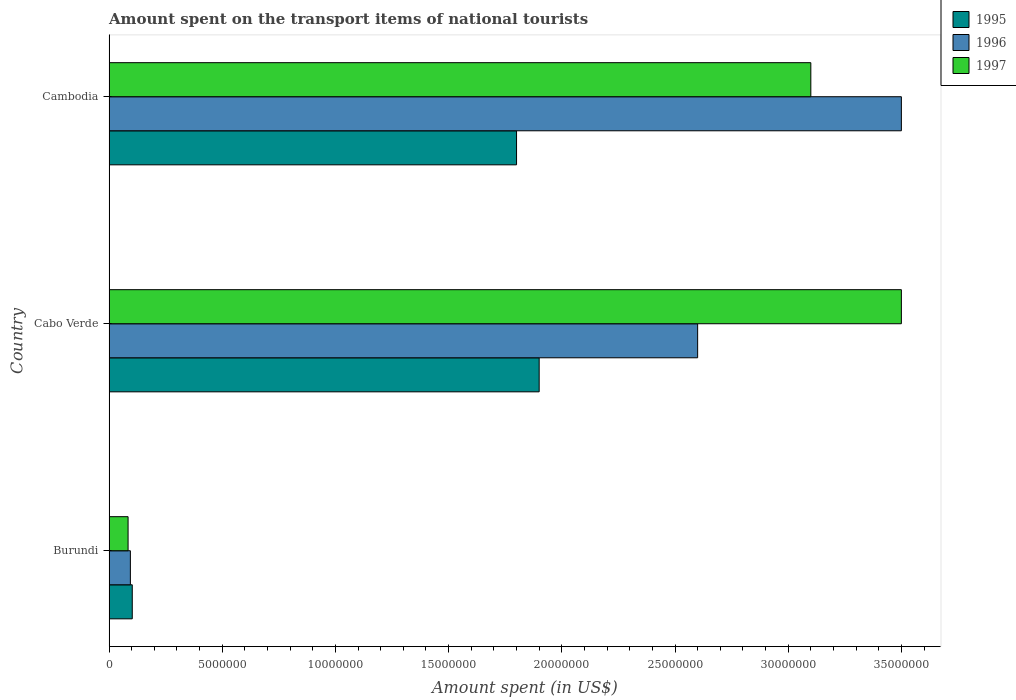How many different coloured bars are there?
Offer a terse response. 3. How many groups of bars are there?
Provide a succinct answer. 3. Are the number of bars on each tick of the Y-axis equal?
Make the answer very short. Yes. How many bars are there on the 2nd tick from the bottom?
Offer a terse response. 3. What is the label of the 2nd group of bars from the top?
Keep it short and to the point. Cabo Verde. In how many cases, is the number of bars for a given country not equal to the number of legend labels?
Offer a terse response. 0. What is the amount spent on the transport items of national tourists in 1996 in Cabo Verde?
Provide a succinct answer. 2.60e+07. Across all countries, what is the maximum amount spent on the transport items of national tourists in 1997?
Keep it short and to the point. 3.50e+07. Across all countries, what is the minimum amount spent on the transport items of national tourists in 1997?
Your answer should be very brief. 8.40e+05. In which country was the amount spent on the transport items of national tourists in 1996 maximum?
Offer a terse response. Cambodia. In which country was the amount spent on the transport items of national tourists in 1995 minimum?
Provide a succinct answer. Burundi. What is the total amount spent on the transport items of national tourists in 1996 in the graph?
Offer a very short reply. 6.19e+07. What is the difference between the amount spent on the transport items of national tourists in 1996 in Cabo Verde and that in Cambodia?
Your answer should be compact. -9.00e+06. What is the difference between the amount spent on the transport items of national tourists in 1995 in Cabo Verde and the amount spent on the transport items of national tourists in 1997 in Cambodia?
Offer a very short reply. -1.20e+07. What is the average amount spent on the transport items of national tourists in 1996 per country?
Your response must be concise. 2.06e+07. What is the difference between the amount spent on the transport items of national tourists in 1995 and amount spent on the transport items of national tourists in 1996 in Burundi?
Ensure brevity in your answer.  8.36e+04. What is the ratio of the amount spent on the transport items of national tourists in 1997 in Cabo Verde to that in Cambodia?
Keep it short and to the point. 1.13. What is the difference between the highest and the lowest amount spent on the transport items of national tourists in 1995?
Ensure brevity in your answer.  1.80e+07. In how many countries, is the amount spent on the transport items of national tourists in 1996 greater than the average amount spent on the transport items of national tourists in 1996 taken over all countries?
Keep it short and to the point. 2. Is it the case that in every country, the sum of the amount spent on the transport items of national tourists in 1995 and amount spent on the transport items of national tourists in 1997 is greater than the amount spent on the transport items of national tourists in 1996?
Offer a terse response. Yes. How many bars are there?
Your answer should be compact. 9. Are all the bars in the graph horizontal?
Provide a short and direct response. Yes. How many countries are there in the graph?
Make the answer very short. 3. What is the title of the graph?
Your answer should be compact. Amount spent on the transport items of national tourists. Does "2004" appear as one of the legend labels in the graph?
Provide a succinct answer. No. What is the label or title of the X-axis?
Offer a very short reply. Amount spent (in US$). What is the Amount spent (in US$) in 1995 in Burundi?
Offer a terse response. 1.02e+06. What is the Amount spent (in US$) of 1996 in Burundi?
Offer a very short reply. 9.41e+05. What is the Amount spent (in US$) in 1997 in Burundi?
Offer a terse response. 8.40e+05. What is the Amount spent (in US$) of 1995 in Cabo Verde?
Keep it short and to the point. 1.90e+07. What is the Amount spent (in US$) in 1996 in Cabo Verde?
Offer a very short reply. 2.60e+07. What is the Amount spent (in US$) of 1997 in Cabo Verde?
Your response must be concise. 3.50e+07. What is the Amount spent (in US$) of 1995 in Cambodia?
Give a very brief answer. 1.80e+07. What is the Amount spent (in US$) of 1996 in Cambodia?
Offer a very short reply. 3.50e+07. What is the Amount spent (in US$) of 1997 in Cambodia?
Your answer should be compact. 3.10e+07. Across all countries, what is the maximum Amount spent (in US$) in 1995?
Offer a terse response. 1.90e+07. Across all countries, what is the maximum Amount spent (in US$) in 1996?
Keep it short and to the point. 3.50e+07. Across all countries, what is the maximum Amount spent (in US$) in 1997?
Ensure brevity in your answer.  3.50e+07. Across all countries, what is the minimum Amount spent (in US$) of 1995?
Your answer should be very brief. 1.02e+06. Across all countries, what is the minimum Amount spent (in US$) of 1996?
Ensure brevity in your answer.  9.41e+05. Across all countries, what is the minimum Amount spent (in US$) of 1997?
Your answer should be very brief. 8.40e+05. What is the total Amount spent (in US$) in 1995 in the graph?
Offer a terse response. 3.80e+07. What is the total Amount spent (in US$) in 1996 in the graph?
Your answer should be compact. 6.19e+07. What is the total Amount spent (in US$) of 1997 in the graph?
Give a very brief answer. 6.68e+07. What is the difference between the Amount spent (in US$) in 1995 in Burundi and that in Cabo Verde?
Your answer should be compact. -1.80e+07. What is the difference between the Amount spent (in US$) in 1996 in Burundi and that in Cabo Verde?
Provide a short and direct response. -2.51e+07. What is the difference between the Amount spent (in US$) of 1997 in Burundi and that in Cabo Verde?
Provide a succinct answer. -3.42e+07. What is the difference between the Amount spent (in US$) of 1995 in Burundi and that in Cambodia?
Your response must be concise. -1.70e+07. What is the difference between the Amount spent (in US$) in 1996 in Burundi and that in Cambodia?
Offer a very short reply. -3.41e+07. What is the difference between the Amount spent (in US$) of 1997 in Burundi and that in Cambodia?
Ensure brevity in your answer.  -3.02e+07. What is the difference between the Amount spent (in US$) in 1996 in Cabo Verde and that in Cambodia?
Ensure brevity in your answer.  -9.00e+06. What is the difference between the Amount spent (in US$) of 1997 in Cabo Verde and that in Cambodia?
Make the answer very short. 4.00e+06. What is the difference between the Amount spent (in US$) of 1995 in Burundi and the Amount spent (in US$) of 1996 in Cabo Verde?
Your answer should be compact. -2.50e+07. What is the difference between the Amount spent (in US$) in 1995 in Burundi and the Amount spent (in US$) in 1997 in Cabo Verde?
Offer a terse response. -3.40e+07. What is the difference between the Amount spent (in US$) of 1996 in Burundi and the Amount spent (in US$) of 1997 in Cabo Verde?
Offer a terse response. -3.41e+07. What is the difference between the Amount spent (in US$) in 1995 in Burundi and the Amount spent (in US$) in 1996 in Cambodia?
Your answer should be very brief. -3.40e+07. What is the difference between the Amount spent (in US$) of 1995 in Burundi and the Amount spent (in US$) of 1997 in Cambodia?
Provide a succinct answer. -3.00e+07. What is the difference between the Amount spent (in US$) of 1996 in Burundi and the Amount spent (in US$) of 1997 in Cambodia?
Ensure brevity in your answer.  -3.01e+07. What is the difference between the Amount spent (in US$) of 1995 in Cabo Verde and the Amount spent (in US$) of 1996 in Cambodia?
Your answer should be compact. -1.60e+07. What is the difference between the Amount spent (in US$) of 1995 in Cabo Verde and the Amount spent (in US$) of 1997 in Cambodia?
Provide a short and direct response. -1.20e+07. What is the difference between the Amount spent (in US$) of 1996 in Cabo Verde and the Amount spent (in US$) of 1997 in Cambodia?
Your answer should be compact. -5.00e+06. What is the average Amount spent (in US$) of 1995 per country?
Your answer should be compact. 1.27e+07. What is the average Amount spent (in US$) of 1996 per country?
Your answer should be compact. 2.06e+07. What is the average Amount spent (in US$) in 1997 per country?
Give a very brief answer. 2.23e+07. What is the difference between the Amount spent (in US$) of 1995 and Amount spent (in US$) of 1996 in Burundi?
Your answer should be very brief. 8.36e+04. What is the difference between the Amount spent (in US$) in 1995 and Amount spent (in US$) in 1997 in Burundi?
Make the answer very short. 1.85e+05. What is the difference between the Amount spent (in US$) of 1996 and Amount spent (in US$) of 1997 in Burundi?
Your response must be concise. 1.01e+05. What is the difference between the Amount spent (in US$) in 1995 and Amount spent (in US$) in 1996 in Cabo Verde?
Provide a succinct answer. -7.00e+06. What is the difference between the Amount spent (in US$) of 1995 and Amount spent (in US$) of 1997 in Cabo Verde?
Your response must be concise. -1.60e+07. What is the difference between the Amount spent (in US$) in 1996 and Amount spent (in US$) in 1997 in Cabo Verde?
Your answer should be very brief. -9.00e+06. What is the difference between the Amount spent (in US$) of 1995 and Amount spent (in US$) of 1996 in Cambodia?
Make the answer very short. -1.70e+07. What is the difference between the Amount spent (in US$) in 1995 and Amount spent (in US$) in 1997 in Cambodia?
Give a very brief answer. -1.30e+07. What is the difference between the Amount spent (in US$) of 1996 and Amount spent (in US$) of 1997 in Cambodia?
Your answer should be compact. 4.00e+06. What is the ratio of the Amount spent (in US$) in 1995 in Burundi to that in Cabo Verde?
Offer a very short reply. 0.05. What is the ratio of the Amount spent (in US$) in 1996 in Burundi to that in Cabo Verde?
Your answer should be very brief. 0.04. What is the ratio of the Amount spent (in US$) of 1997 in Burundi to that in Cabo Verde?
Offer a very short reply. 0.02. What is the ratio of the Amount spent (in US$) of 1995 in Burundi to that in Cambodia?
Offer a very short reply. 0.06. What is the ratio of the Amount spent (in US$) of 1996 in Burundi to that in Cambodia?
Keep it short and to the point. 0.03. What is the ratio of the Amount spent (in US$) in 1997 in Burundi to that in Cambodia?
Ensure brevity in your answer.  0.03. What is the ratio of the Amount spent (in US$) of 1995 in Cabo Verde to that in Cambodia?
Provide a short and direct response. 1.06. What is the ratio of the Amount spent (in US$) in 1996 in Cabo Verde to that in Cambodia?
Make the answer very short. 0.74. What is the ratio of the Amount spent (in US$) in 1997 in Cabo Verde to that in Cambodia?
Give a very brief answer. 1.13. What is the difference between the highest and the second highest Amount spent (in US$) in 1996?
Give a very brief answer. 9.00e+06. What is the difference between the highest and the lowest Amount spent (in US$) of 1995?
Your response must be concise. 1.80e+07. What is the difference between the highest and the lowest Amount spent (in US$) in 1996?
Provide a succinct answer. 3.41e+07. What is the difference between the highest and the lowest Amount spent (in US$) in 1997?
Your response must be concise. 3.42e+07. 